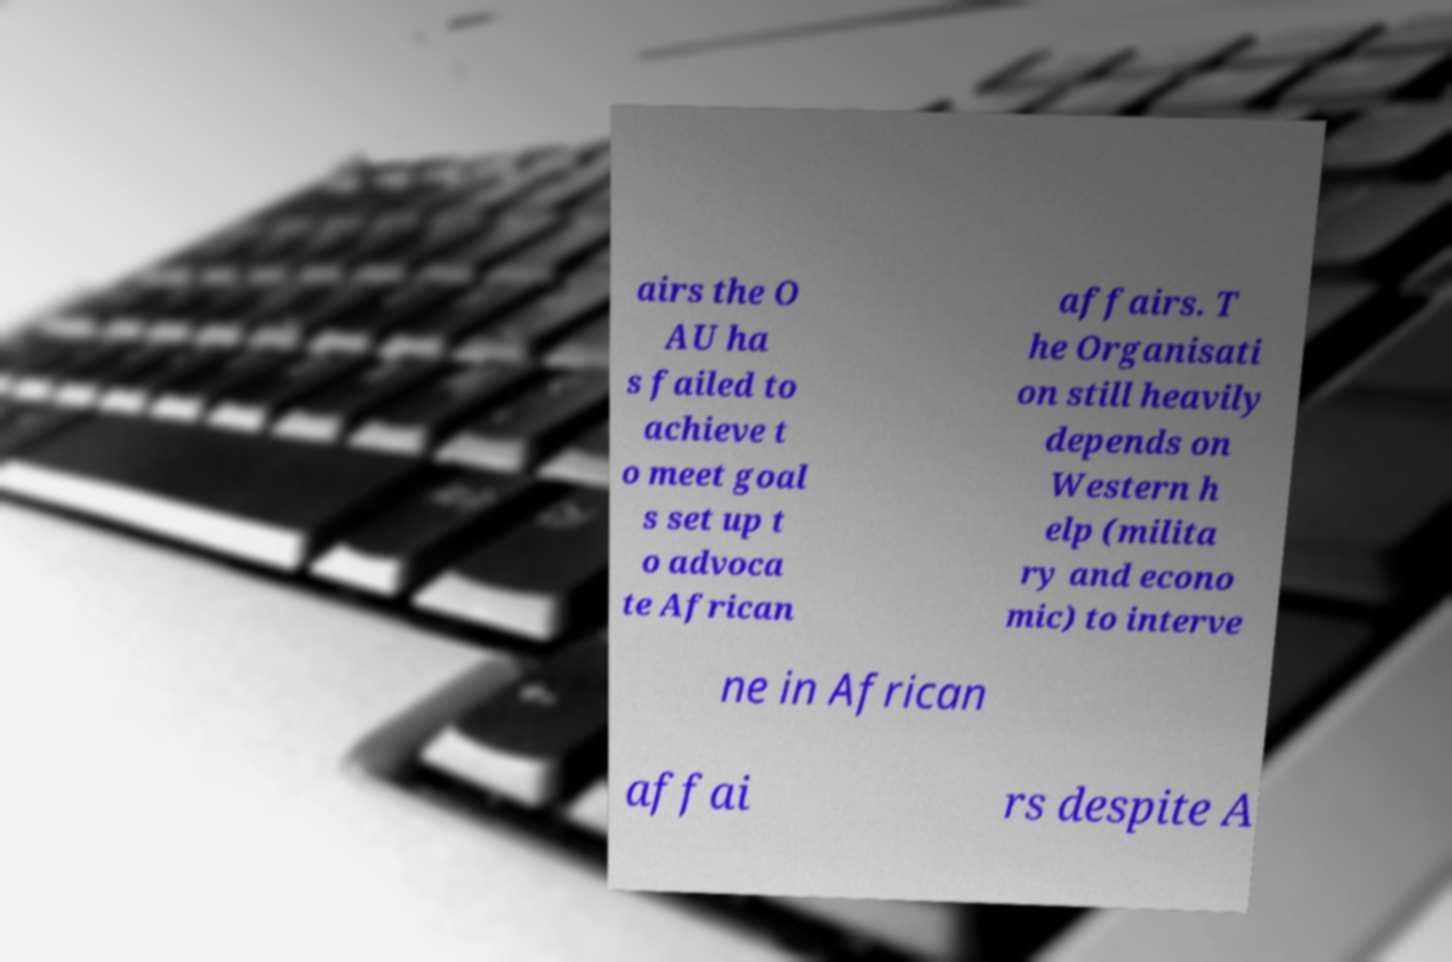Please read and relay the text visible in this image. What does it say? airs the O AU ha s failed to achieve t o meet goal s set up t o advoca te African affairs. T he Organisati on still heavily depends on Western h elp (milita ry and econo mic) to interve ne in African affai rs despite A 